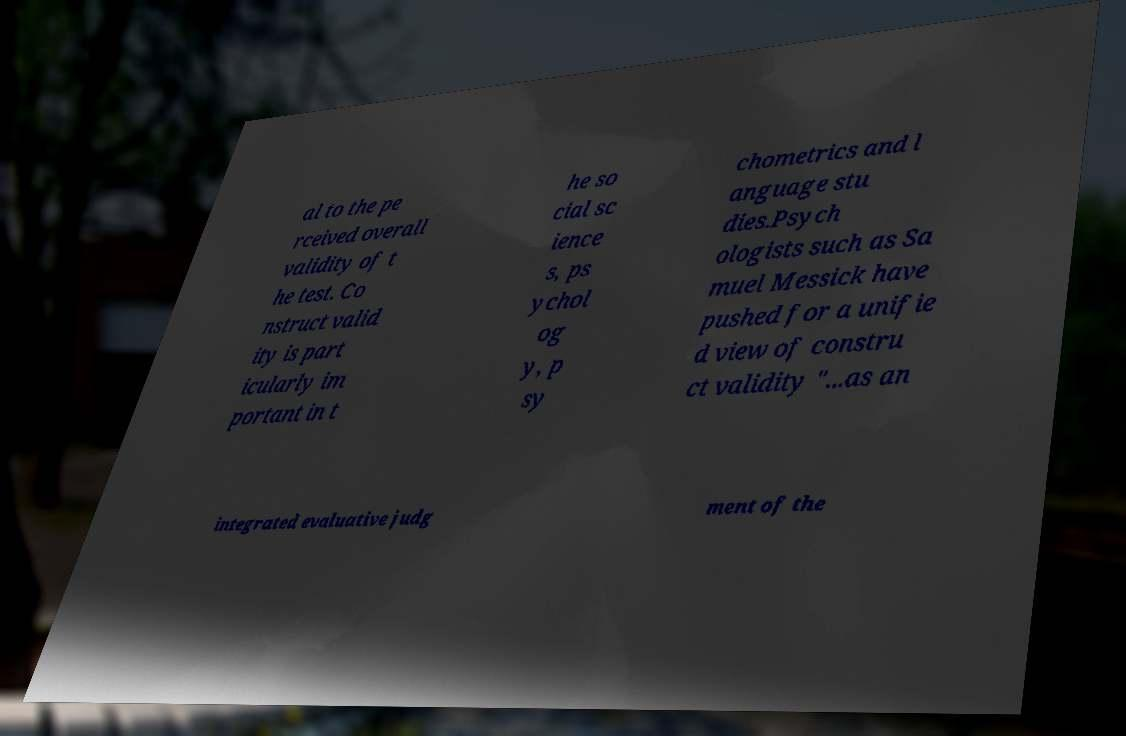Could you assist in decoding the text presented in this image and type it out clearly? al to the pe rceived overall validity of t he test. Co nstruct valid ity is part icularly im portant in t he so cial sc ience s, ps ychol og y, p sy chometrics and l anguage stu dies.Psych ologists such as Sa muel Messick have pushed for a unifie d view of constru ct validity "...as an integrated evaluative judg ment of the 